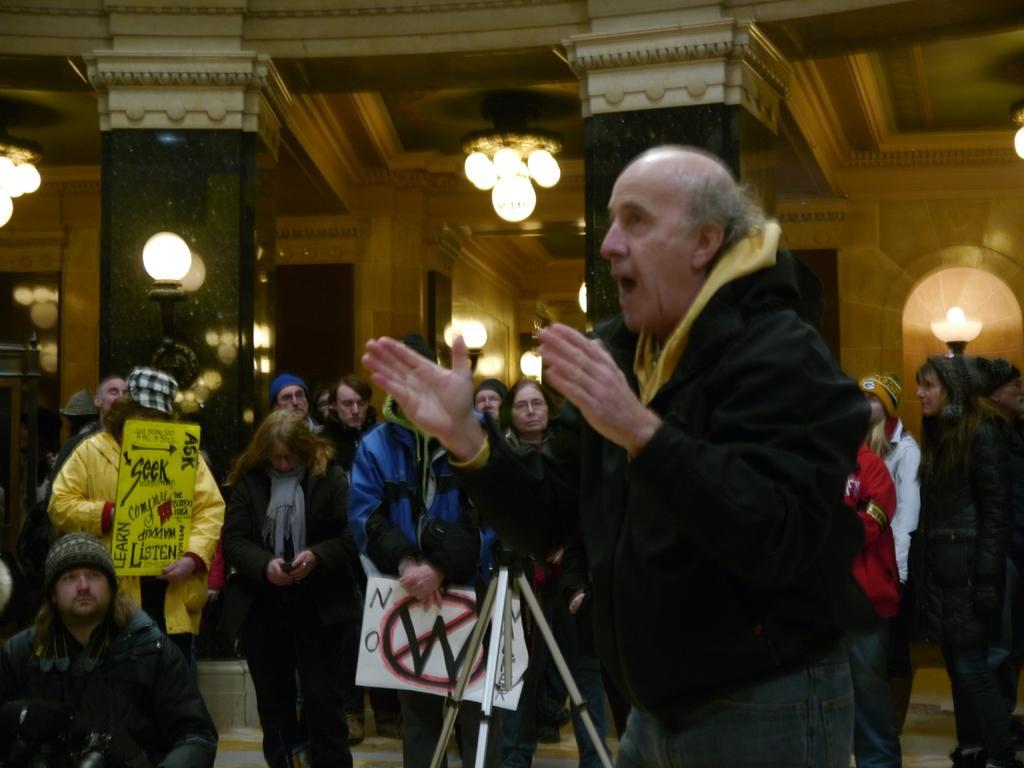In one or two sentences, can you explain what this image depicts? In the image there are many people and few of them are holding some posters their hands with some text and pictures and in the background there are pillars, lights and wall. 